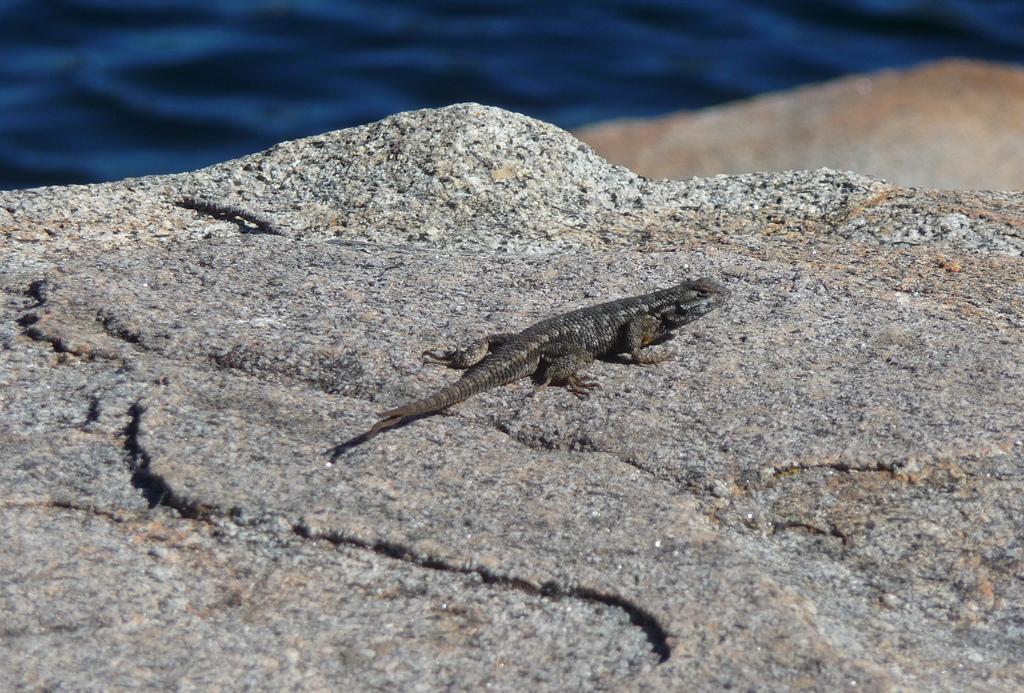Please provide a concise description of this image. In this image we can see lizard which is on stone and the background image is blur. 